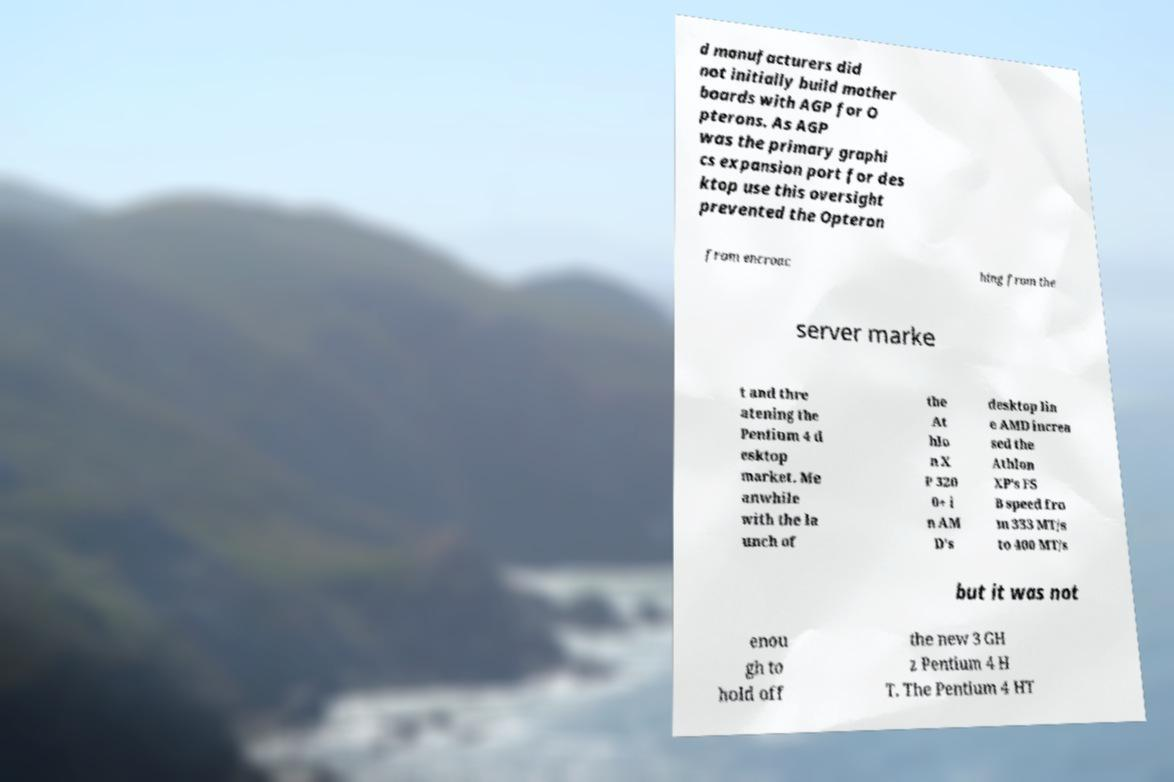What messages or text are displayed in this image? I need them in a readable, typed format. d manufacturers did not initially build mother boards with AGP for O pterons. As AGP was the primary graphi cs expansion port for des ktop use this oversight prevented the Opteron from encroac hing from the server marke t and thre atening the Pentium 4 d esktop market. Me anwhile with the la unch of the At hlo n X P 320 0+ i n AM D's desktop lin e AMD increa sed the Athlon XP's FS B speed fro m 333 MT/s to 400 MT/s but it was not enou gh to hold off the new 3 GH z Pentium 4 H T. The Pentium 4 HT 